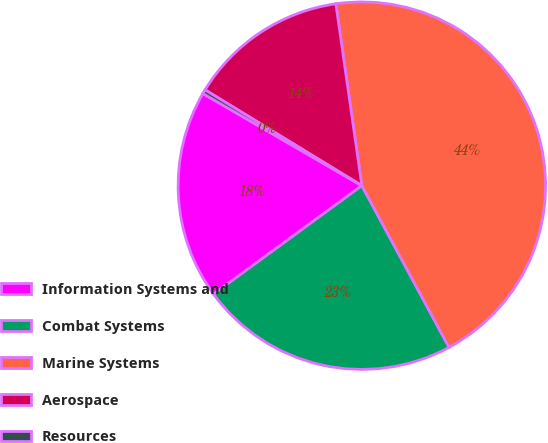<chart> <loc_0><loc_0><loc_500><loc_500><pie_chart><fcel>Information Systems and<fcel>Combat Systems<fcel>Marine Systems<fcel>Aerospace<fcel>Resources<nl><fcel>18.41%<fcel>22.82%<fcel>44.39%<fcel>14.01%<fcel>0.37%<nl></chart> 